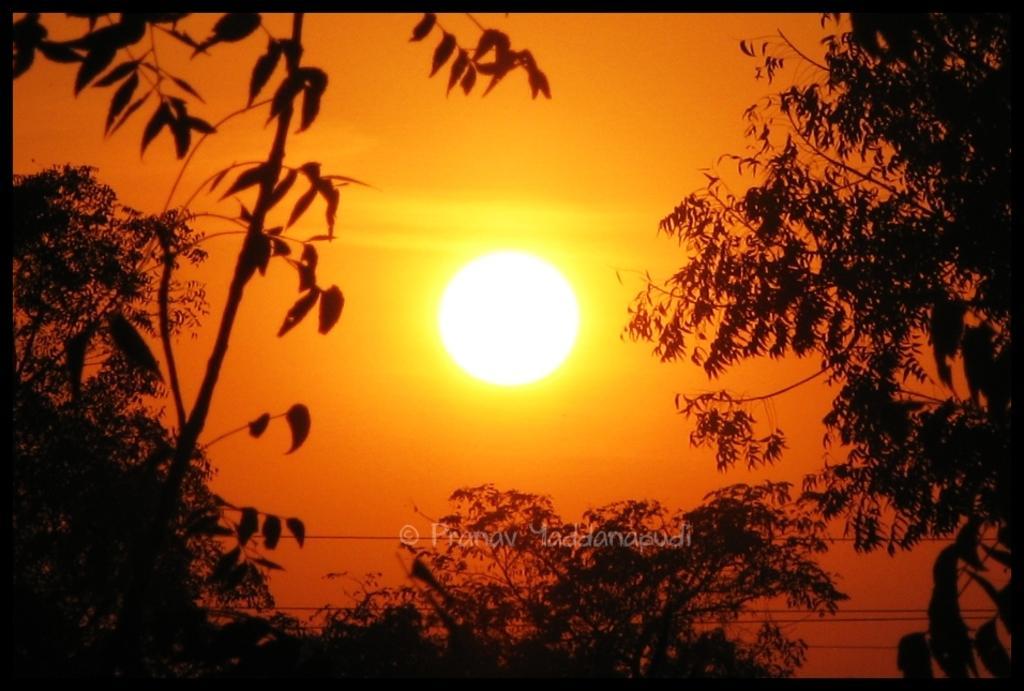Can you describe this image briefly? Here we can see the sun and trees. On this image there is a watermark.  